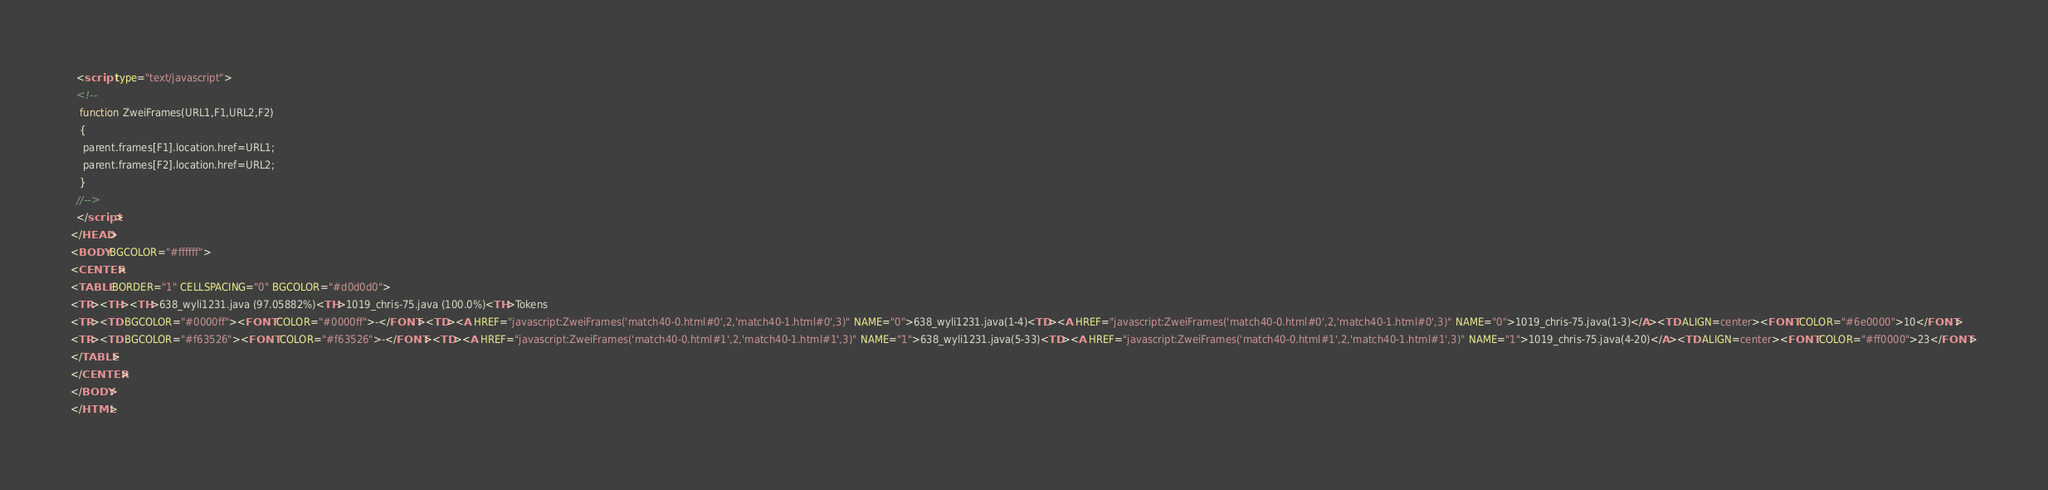<code> <loc_0><loc_0><loc_500><loc_500><_HTML_>  <script type="text/javascript">
  <!--
   function ZweiFrames(URL1,F1,URL2,F2)
   {
    parent.frames[F1].location.href=URL1;
    parent.frames[F2].location.href=URL2;
   }
  //-->
  </script>
</HEAD>
<BODY BGCOLOR="#ffffff">
<CENTER>
<TABLE BORDER="1" CELLSPACING="0" BGCOLOR="#d0d0d0">
<TR><TH><TH>638_wyli1231.java (97.05882%)<TH>1019_chris-75.java (100.0%)<TH>Tokens
<TR><TD BGCOLOR="#0000ff"><FONT COLOR="#0000ff">-</FONT><TD><A HREF="javascript:ZweiFrames('match40-0.html#0',2,'match40-1.html#0',3)" NAME="0">638_wyli1231.java(1-4)<TD><A HREF="javascript:ZweiFrames('match40-0.html#0',2,'match40-1.html#0',3)" NAME="0">1019_chris-75.java(1-3)</A><TD ALIGN=center><FONT COLOR="#6e0000">10</FONT>
<TR><TD BGCOLOR="#f63526"><FONT COLOR="#f63526">-</FONT><TD><A HREF="javascript:ZweiFrames('match40-0.html#1',2,'match40-1.html#1',3)" NAME="1">638_wyli1231.java(5-33)<TD><A HREF="javascript:ZweiFrames('match40-0.html#1',2,'match40-1.html#1',3)" NAME="1">1019_chris-75.java(4-20)</A><TD ALIGN=center><FONT COLOR="#ff0000">23</FONT>
</TABLE>
</CENTER>
</BODY>
</HTML>

</code> 